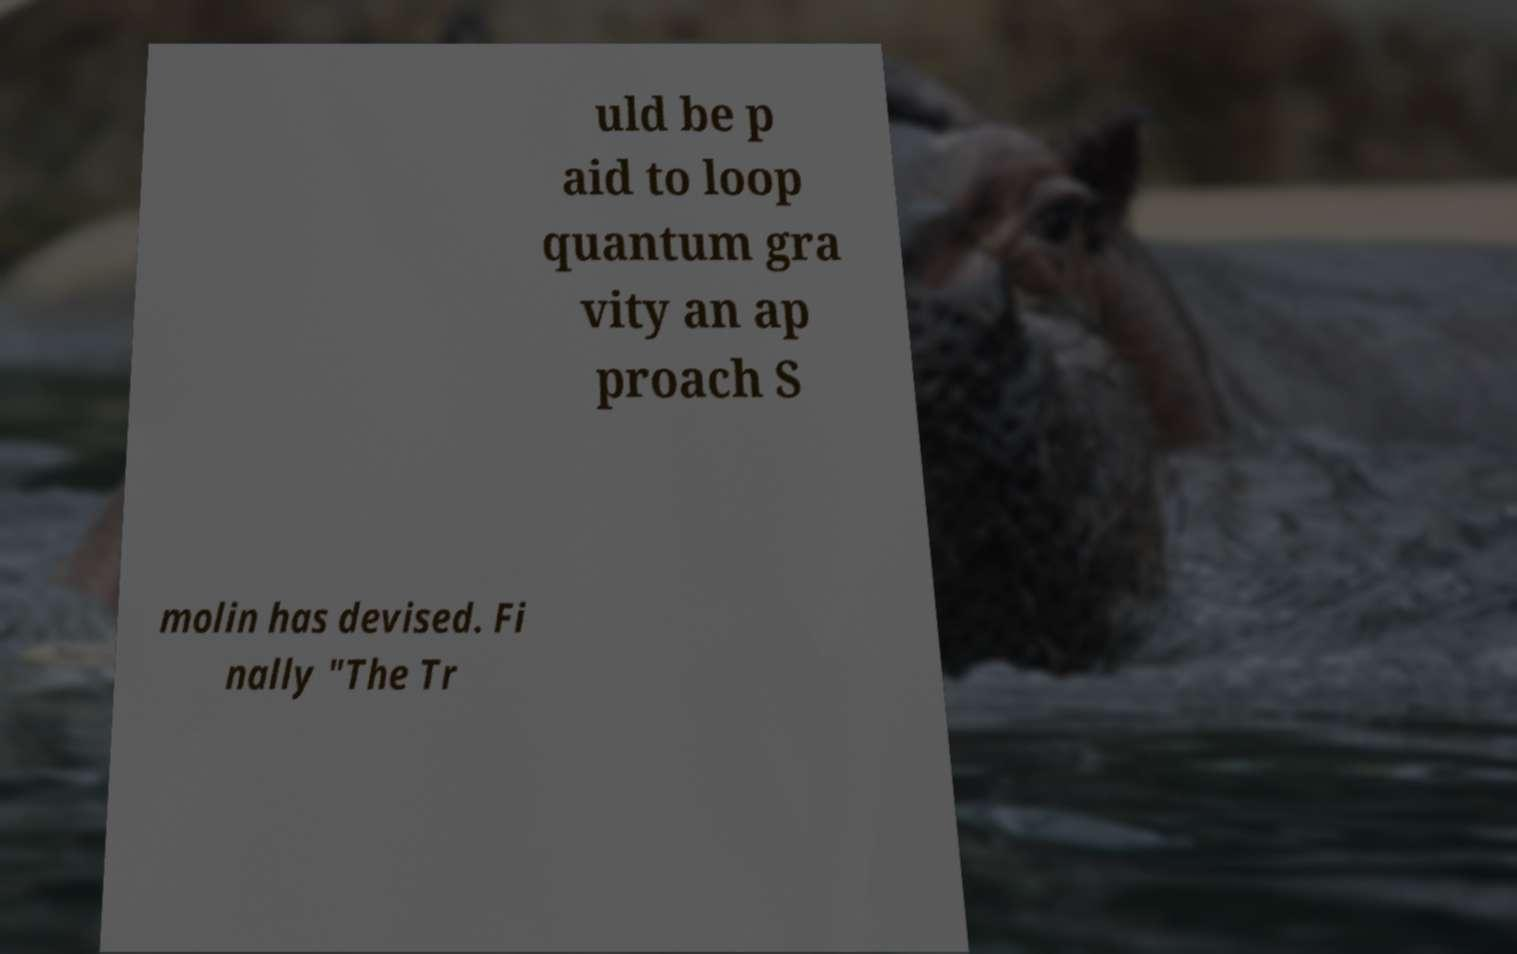Can you accurately transcribe the text from the provided image for me? uld be p aid to loop quantum gra vity an ap proach S molin has devised. Fi nally "The Tr 